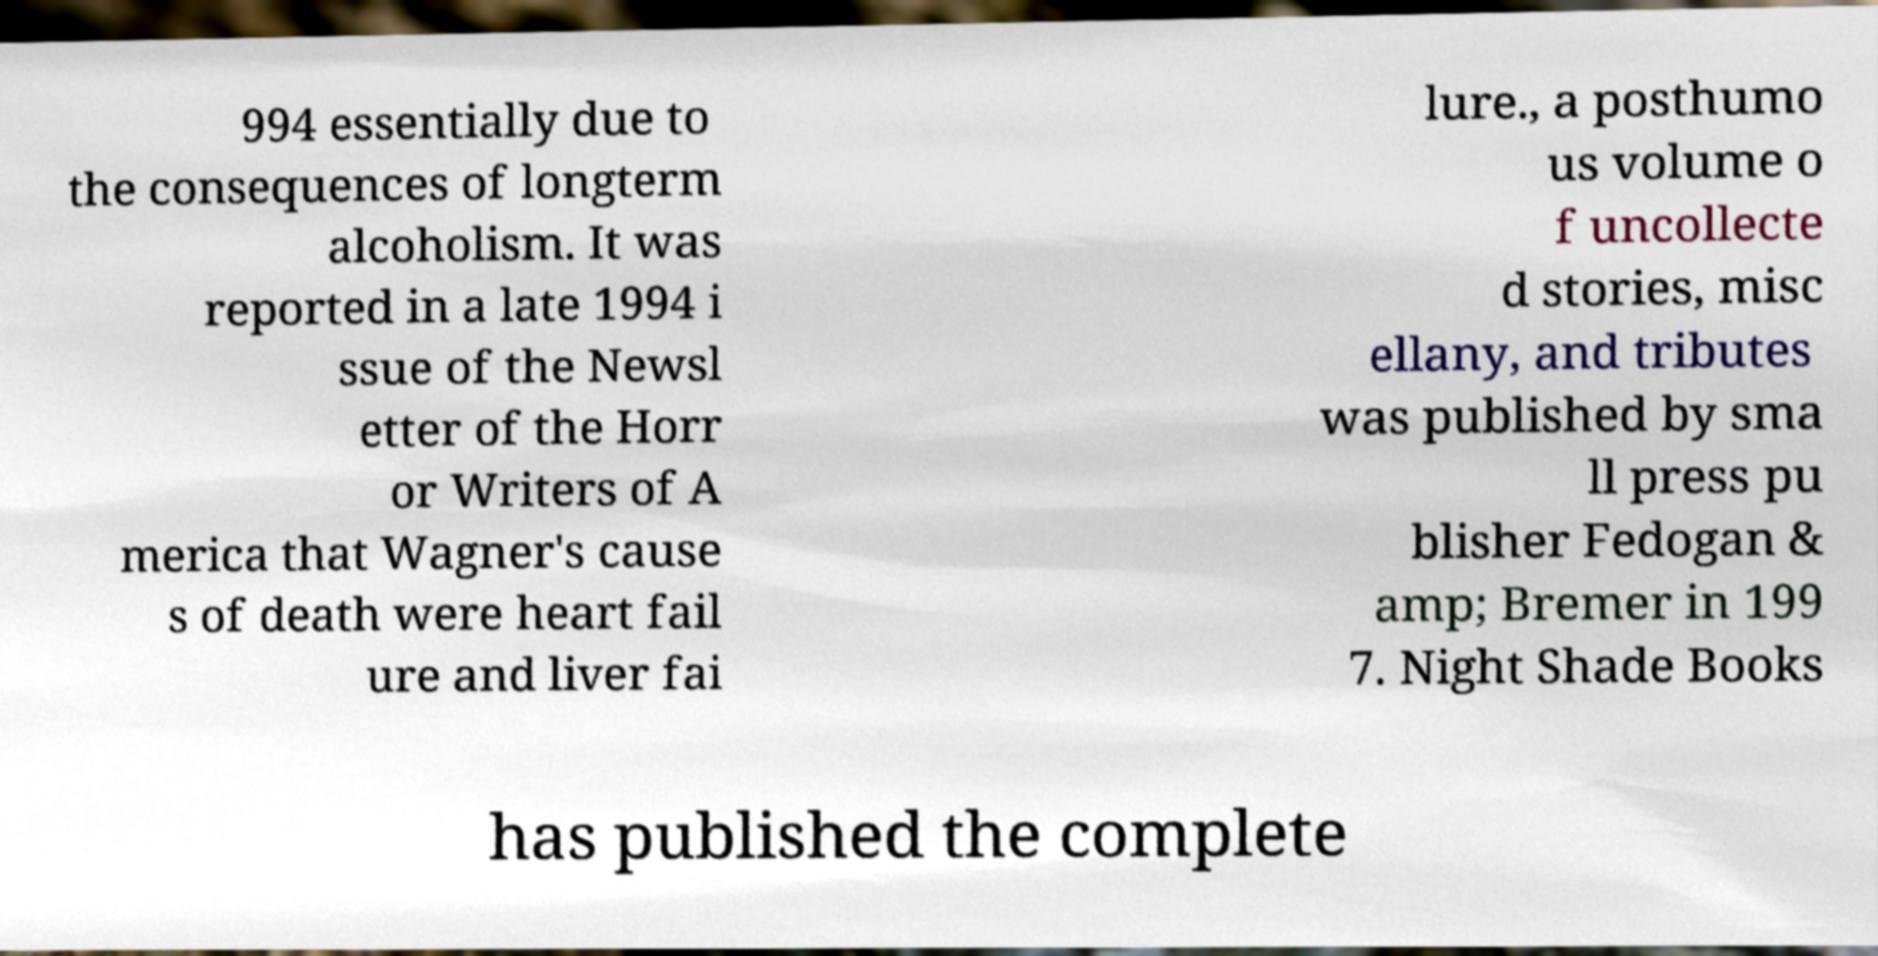I need the written content from this picture converted into text. Can you do that? 994 essentially due to the consequences of longterm alcoholism. It was reported in a late 1994 i ssue of the Newsl etter of the Horr or Writers of A merica that Wagner's cause s of death were heart fail ure and liver fai lure., a posthumo us volume o f uncollecte d stories, misc ellany, and tributes was published by sma ll press pu blisher Fedogan & amp; Bremer in 199 7. Night Shade Books has published the complete 